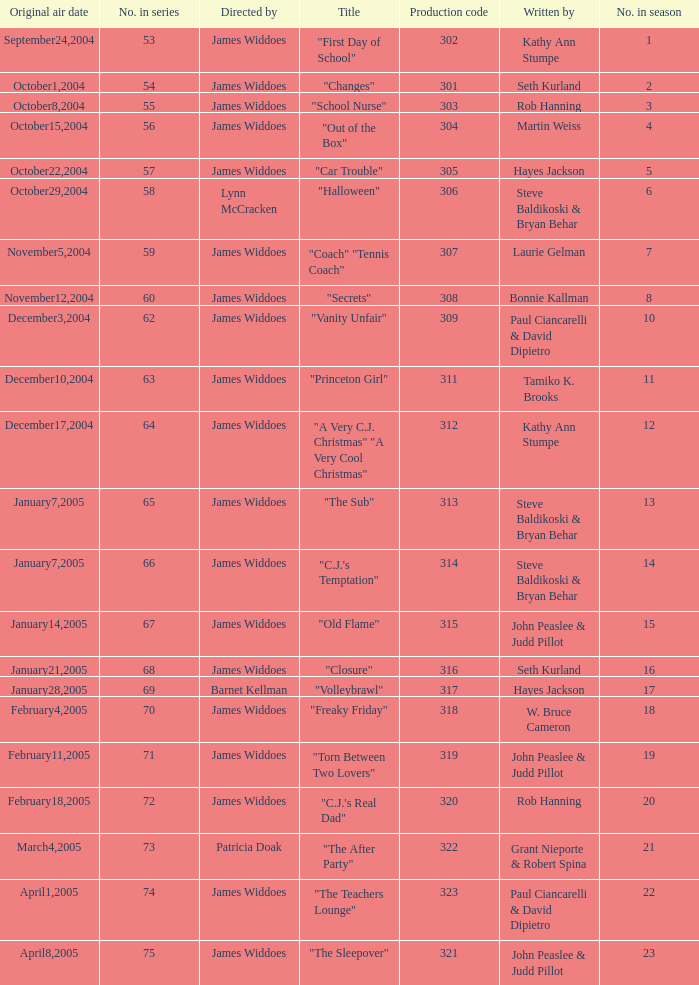What date was the episode originally aired that was directed by James Widdoes and the production code is 320? February18,2005. 